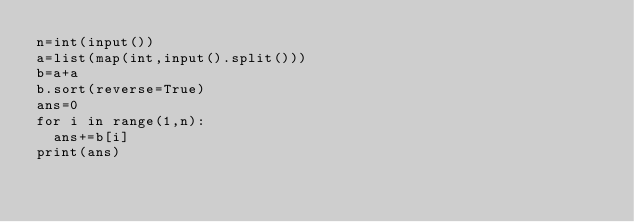Convert code to text. <code><loc_0><loc_0><loc_500><loc_500><_Python_>n=int(input())
a=list(map(int,input().split()))
b=a+a
b.sort(reverse=True)
ans=0
for i in range(1,n):
  ans+=b[i]
print(ans)</code> 